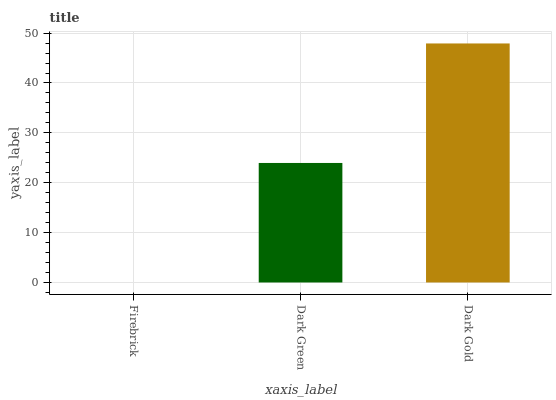Is Dark Green the minimum?
Answer yes or no. No. Is Dark Green the maximum?
Answer yes or no. No. Is Dark Green greater than Firebrick?
Answer yes or no. Yes. Is Firebrick less than Dark Green?
Answer yes or no. Yes. Is Firebrick greater than Dark Green?
Answer yes or no. No. Is Dark Green less than Firebrick?
Answer yes or no. No. Is Dark Green the high median?
Answer yes or no. Yes. Is Dark Green the low median?
Answer yes or no. Yes. Is Firebrick the high median?
Answer yes or no. No. Is Firebrick the low median?
Answer yes or no. No. 